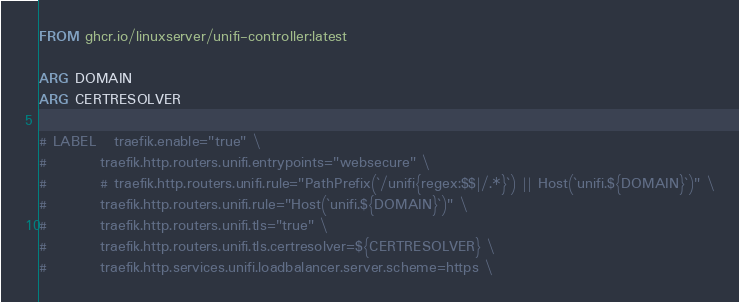<code> <loc_0><loc_0><loc_500><loc_500><_Dockerfile_>FROM ghcr.io/linuxserver/unifi-controller:latest

ARG DOMAIN
ARG CERTRESOLVER

# LABEL   traefik.enable="true" \
#         traefik.http.routers.unifi.entrypoints="websecure" \
#         # traefik.http.routers.unifi.rule="PathPrefix(`/unifi{regex:$$|/.*}`) || Host(`unifi.${DOMAIN}`)" \
#         traefik.http.routers.unifi.rule="Host(`unifi.${DOMAIN}`)" \
#         traefik.http.routers.unifi.tls="true" \
#         traefik.http.routers.unifi.tls.certresolver=${CERTRESOLVER} \
#         traefik.http.services.unifi.loadbalancer.server.scheme=https \</code> 